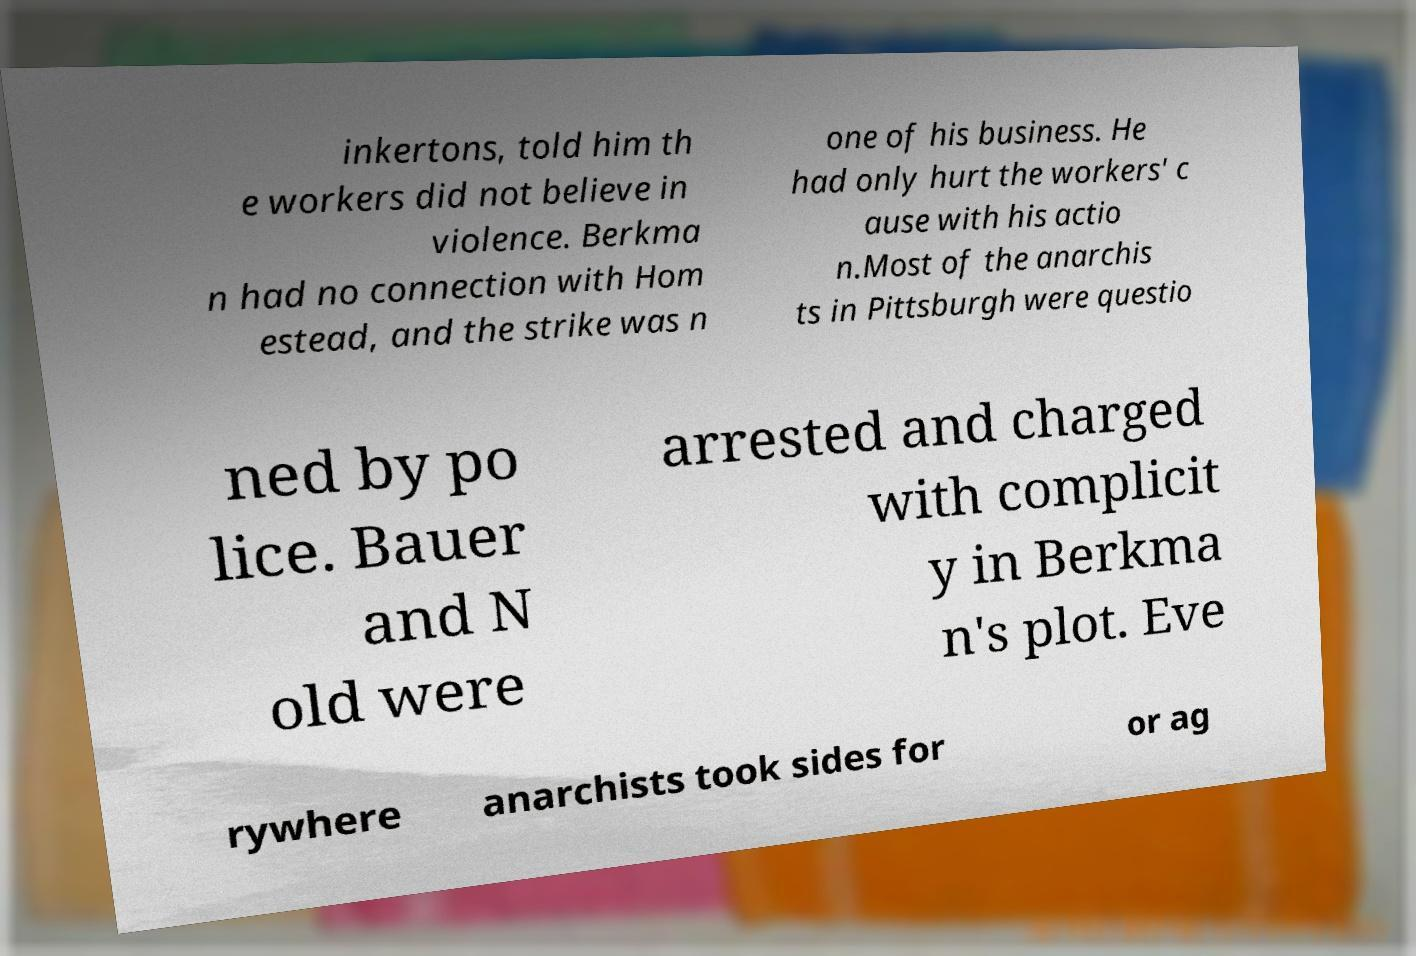Could you extract and type out the text from this image? inkertons, told him th e workers did not believe in violence. Berkma n had no connection with Hom estead, and the strike was n one of his business. He had only hurt the workers' c ause with his actio n.Most of the anarchis ts in Pittsburgh were questio ned by po lice. Bauer and N old were arrested and charged with complicit y in Berkma n's plot. Eve rywhere anarchists took sides for or ag 